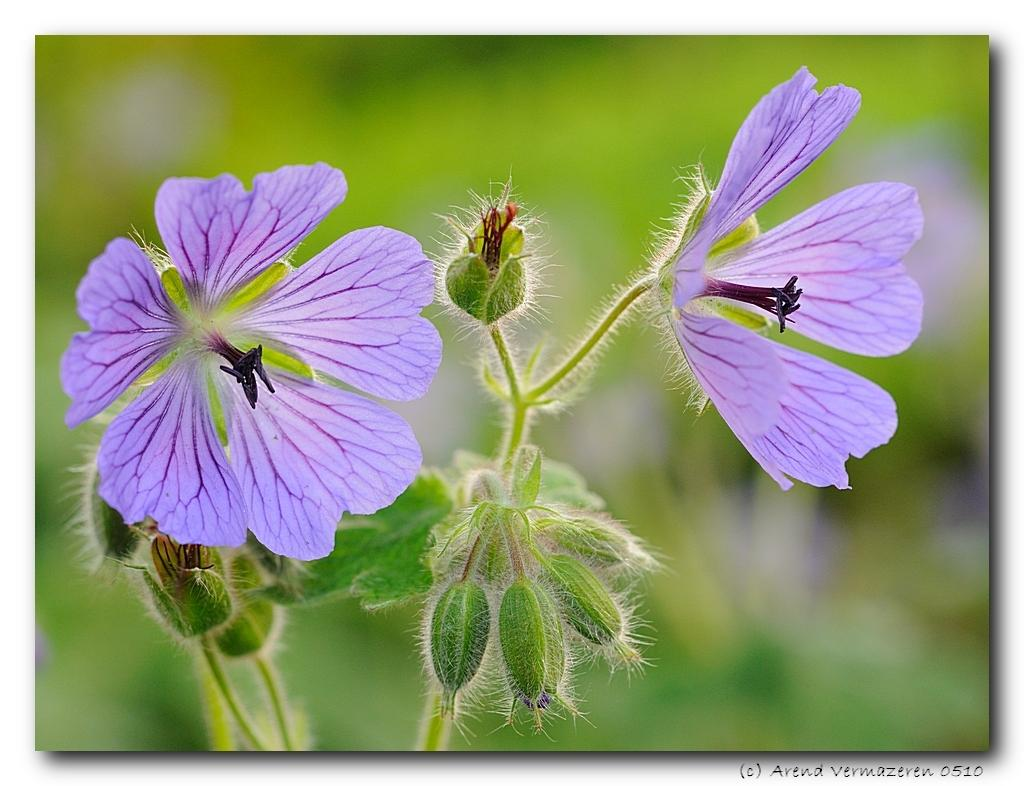What type of plant is visible in the image? There is a plant with flowers and buds in the image. Can you describe the background of the image? The background of the image is blurred. Is there any additional information or markings in the image? Yes, there is a watermark in the bottom right corner of the image. What type of weather can be seen in the image? There is no indication of weather in the image, as it is a close-up of a plant with flowers and buds. What type of action is the plant performing in the image? Plants do not perform actions like humans or animals; they simply grow and produce flowers and buds. 